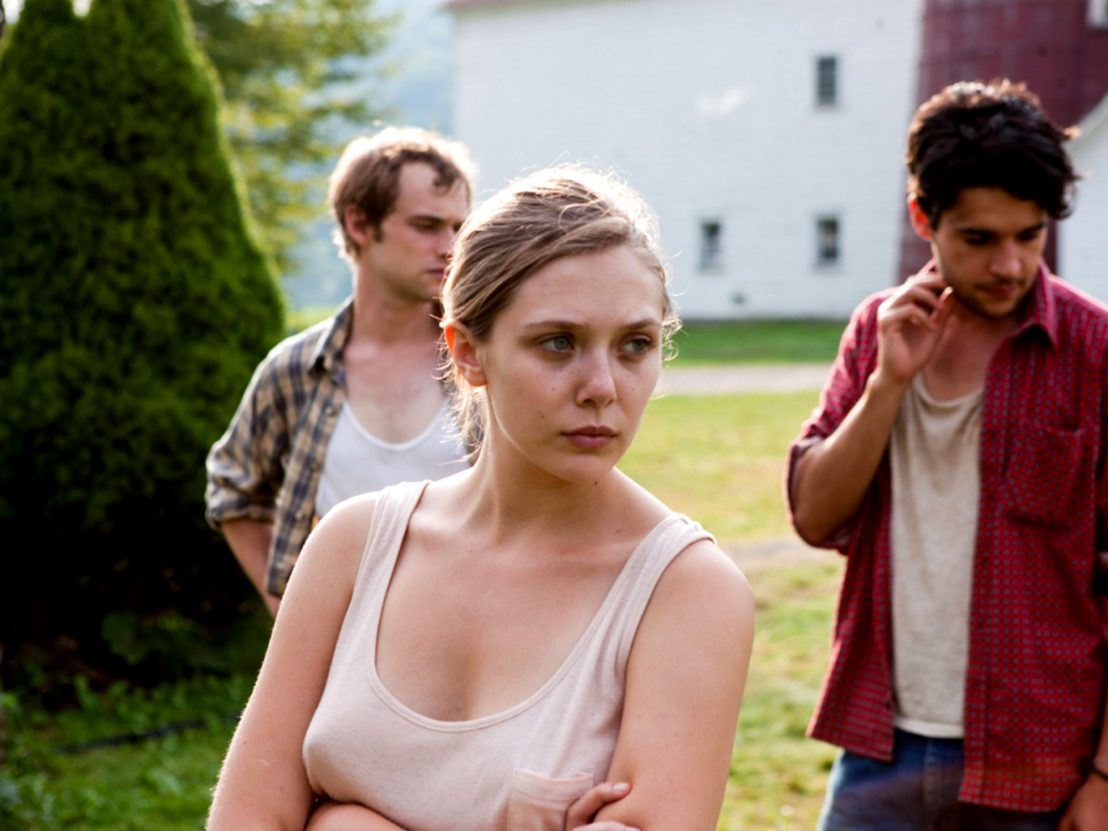What do you think might have happened just before this moment? Before this moment, it is possible that the characters had a serious discussion or confrontation that led to their current state of distress. The central woman’s pensive expression and the concerned looks of the men around her suggest a conversation of significant emotional weight might have taken place. She could have received upsetting news, or they might have been discussing a complicated issue that affects them all deeply. The rural setting with the barn and tree adds a layer of isolation, implying that they needed privacy for this intense conversation, away from others. Describe a possible backstory for these characters. These characters might be part of a family or close-knit community living in this rural area. The woman in the center could be someone who holds a significant responsibility within the group, perhaps a leader or decision-maker. The two men might be her close relatives or confidants who are equally affected by the situation at hand. They might have been raised together, their bond forged through shared experiences in this countryside setting. Recently, they could be facing a challenging situation, such as the sale of their family property, a disagreement over future plans, or dealing with a past event that has resurfaced, bringing emotional turmoil. Their expressions encapsulate the weight of their shared history and the gravity of their current predicament. 